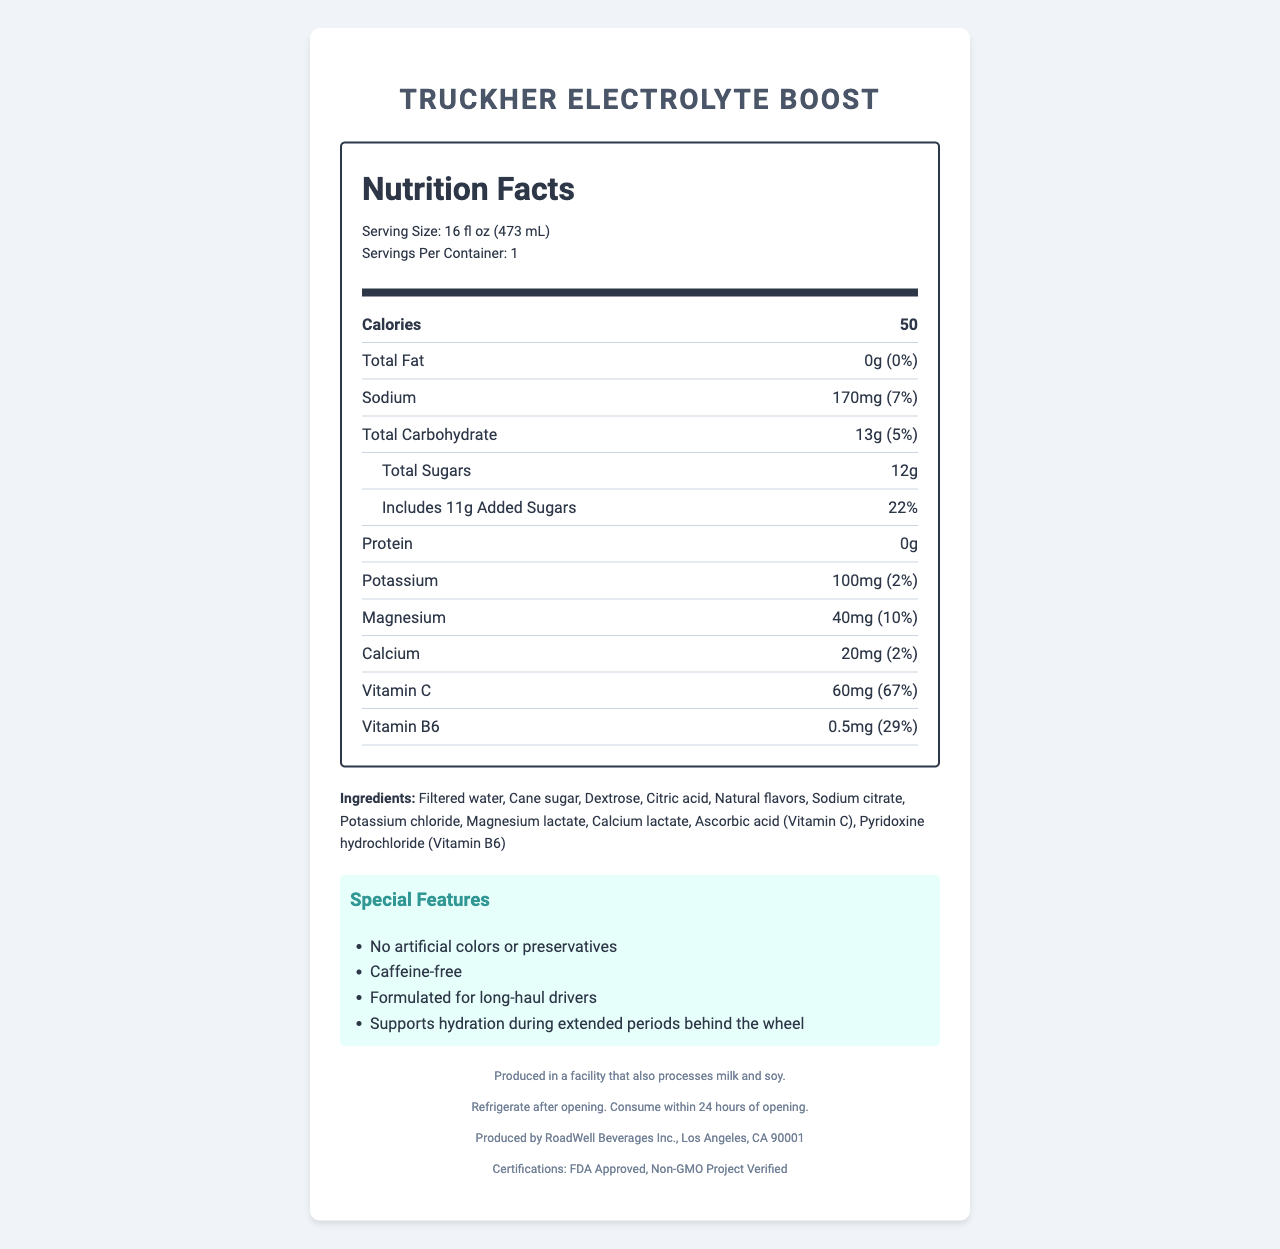what is the serving size of TruckHER Electrolyte Boost? The serving size is listed directly under the Nutrition Facts header.
Answer: 16 fl oz (473 mL) how many calories are in one serving? The calories per serving are displayed prominently in the nutrient rows.
Answer: 50 how much sugars are added per serving? The amount of added sugars is mentioned in the sub-row under Total Sugars.
Answer: 11g what is the daily value percentage of vitamin C in this beverage? The daily value percentage for vitamin C is specified in the nutrient rows.
Answer: 67% what is the recommended storage instruction after opening? The storage instructions are listed in the footer section of the document.
Answer: Refrigerate after opening. Consume within 24 hours of opening. which vitamin has the highest daily value percentage in this beverage? A. Vitamin C B. Vitamin B6 C. Magnesium D. Potassium Vitamin C has a daily value of 67%, which is higher than Vitamin B6 (29%), magnesium (10%), and potassium (2%).
Answer: A what is the manufacturer of TruckHER Electrolyte Boost? A. RoadWell Beverages Inc. B. TruckWell Beverages Inc. C. ElectroWell Beverages Inc. D. HydrateWell Beverages Inc. The manufacturer information is listed in the footer: "Produced by RoadWell Beverages Inc., Los Angeles, CA 90001."
Answer: A does the product contain any artificial colors or preservatives? "No artificial colors or preservatives" is listed under the special features section.
Answer: No summarize the main nutritional benefits of this beverage for long-haul drivers. The document highlights that this beverage is formulated for hydration and energy, especially for long-haul drivers, by providing essential electrolytes and vitamins.
Answer: TruckHER Electrolyte Boost is designed to support hydration with key electrolytes like sodium, potassium, magnesium, and calcium. It contains 50 calories, is caffeine-free, and provides significant daily values of vitamin C (67%) and vitamin B6 (29%), making it a suitable choice for maintaining energy and hydration during long drives. how much sodium does one serving of TruckHER Electrolyte Boost contain? The sodium content per serving is listed in the nutrient rows.
Answer: 170mg what is the daily value percentage of magnesium in this beverage? The daily value percentage for magnesium is specified in the nutrient rows.
Answer: 10% is the beverage GMO-free? The beverage is "Non-GMO Project Verified," as stated in the certifications section.
Answer: Yes what is the calorie count for two servings? The document only mentions that there is one serving per container, so the calorie count for two servings is not applicable based on the provided information.
Answer: Cannot be determined what are the key ingredients in TruckHER Electrolyte Boost that contribute to hydration? These ingredients contribute to hydration and electrolyte balance, as listed in the ingredients section of the document.
Answer: Filtered water, Cane sugar, Dextrose, Sodium citrate, Potassium chloride, Magnesium lactate, Calcium lactate 